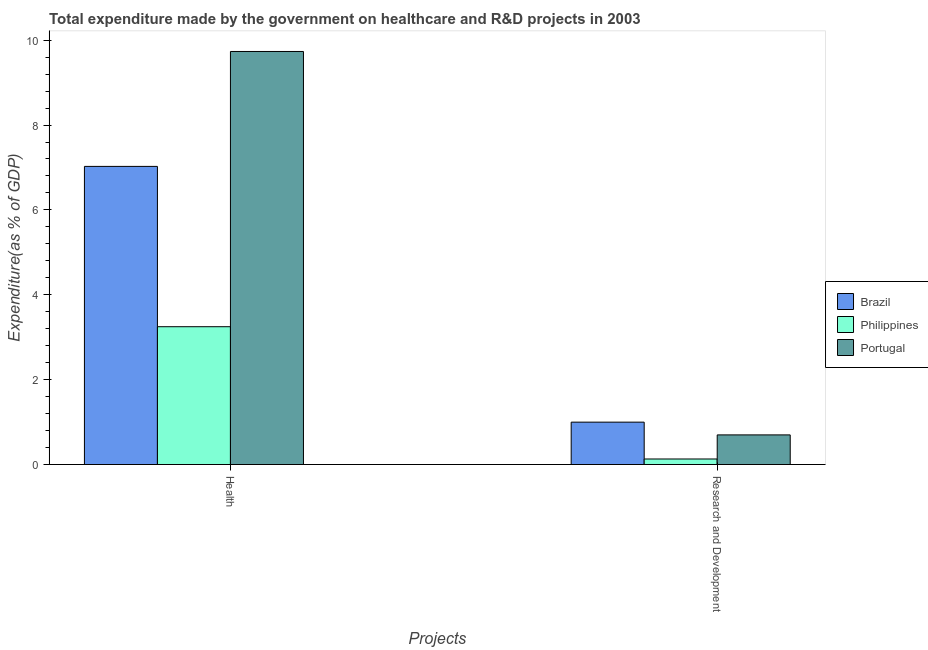Are the number of bars per tick equal to the number of legend labels?
Ensure brevity in your answer.  Yes. Are the number of bars on each tick of the X-axis equal?
Your answer should be compact. Yes. How many bars are there on the 1st tick from the left?
Offer a terse response. 3. What is the label of the 2nd group of bars from the left?
Make the answer very short. Research and Development. What is the expenditure in healthcare in Brazil?
Give a very brief answer. 7.03. Across all countries, what is the maximum expenditure in r&d?
Give a very brief answer. 1. Across all countries, what is the minimum expenditure in healthcare?
Offer a terse response. 3.25. In which country was the expenditure in healthcare maximum?
Provide a short and direct response. Portugal. In which country was the expenditure in r&d minimum?
Ensure brevity in your answer.  Philippines. What is the total expenditure in r&d in the graph?
Make the answer very short. 1.83. What is the difference between the expenditure in healthcare in Brazil and that in Portugal?
Give a very brief answer. -2.71. What is the difference between the expenditure in healthcare in Philippines and the expenditure in r&d in Portugal?
Keep it short and to the point. 2.55. What is the average expenditure in healthcare per country?
Give a very brief answer. 6.67. What is the difference between the expenditure in healthcare and expenditure in r&d in Portugal?
Ensure brevity in your answer.  9.04. In how many countries, is the expenditure in healthcare greater than 7.2 %?
Your response must be concise. 1. What is the ratio of the expenditure in r&d in Portugal to that in Philippines?
Your response must be concise. 5.37. Is the expenditure in healthcare in Portugal less than that in Brazil?
Ensure brevity in your answer.  No. In how many countries, is the expenditure in r&d greater than the average expenditure in r&d taken over all countries?
Provide a succinct answer. 2. What does the 3rd bar from the right in Health represents?
Give a very brief answer. Brazil. Are all the bars in the graph horizontal?
Provide a succinct answer. No. What is the difference between two consecutive major ticks on the Y-axis?
Offer a terse response. 2. Does the graph contain grids?
Your answer should be very brief. No. Where does the legend appear in the graph?
Provide a succinct answer. Center right. How many legend labels are there?
Provide a succinct answer. 3. What is the title of the graph?
Provide a short and direct response. Total expenditure made by the government on healthcare and R&D projects in 2003. What is the label or title of the X-axis?
Ensure brevity in your answer.  Projects. What is the label or title of the Y-axis?
Provide a succinct answer. Expenditure(as % of GDP). What is the Expenditure(as % of GDP) of Brazil in Health?
Offer a terse response. 7.03. What is the Expenditure(as % of GDP) in Philippines in Health?
Offer a very short reply. 3.25. What is the Expenditure(as % of GDP) of Portugal in Health?
Your answer should be very brief. 9.73. What is the Expenditure(as % of GDP) in Brazil in Research and Development?
Offer a terse response. 1. What is the Expenditure(as % of GDP) in Philippines in Research and Development?
Offer a very short reply. 0.13. What is the Expenditure(as % of GDP) in Portugal in Research and Development?
Provide a short and direct response. 0.7. Across all Projects, what is the maximum Expenditure(as % of GDP) in Brazil?
Offer a terse response. 7.03. Across all Projects, what is the maximum Expenditure(as % of GDP) of Philippines?
Provide a succinct answer. 3.25. Across all Projects, what is the maximum Expenditure(as % of GDP) in Portugal?
Make the answer very short. 9.73. Across all Projects, what is the minimum Expenditure(as % of GDP) in Brazil?
Your answer should be compact. 1. Across all Projects, what is the minimum Expenditure(as % of GDP) of Philippines?
Your response must be concise. 0.13. Across all Projects, what is the minimum Expenditure(as % of GDP) of Portugal?
Your answer should be compact. 0.7. What is the total Expenditure(as % of GDP) in Brazil in the graph?
Give a very brief answer. 8.02. What is the total Expenditure(as % of GDP) of Philippines in the graph?
Make the answer very short. 3.38. What is the total Expenditure(as % of GDP) in Portugal in the graph?
Your answer should be very brief. 10.43. What is the difference between the Expenditure(as % of GDP) in Brazil in Health and that in Research and Development?
Keep it short and to the point. 6.03. What is the difference between the Expenditure(as % of GDP) of Philippines in Health and that in Research and Development?
Your answer should be compact. 3.12. What is the difference between the Expenditure(as % of GDP) in Portugal in Health and that in Research and Development?
Your answer should be compact. 9.04. What is the difference between the Expenditure(as % of GDP) in Brazil in Health and the Expenditure(as % of GDP) in Philippines in Research and Development?
Your answer should be compact. 6.9. What is the difference between the Expenditure(as % of GDP) of Brazil in Health and the Expenditure(as % of GDP) of Portugal in Research and Development?
Give a very brief answer. 6.33. What is the difference between the Expenditure(as % of GDP) of Philippines in Health and the Expenditure(as % of GDP) of Portugal in Research and Development?
Ensure brevity in your answer.  2.55. What is the average Expenditure(as % of GDP) in Brazil per Projects?
Make the answer very short. 4.01. What is the average Expenditure(as % of GDP) of Philippines per Projects?
Offer a terse response. 1.69. What is the average Expenditure(as % of GDP) of Portugal per Projects?
Provide a succinct answer. 5.22. What is the difference between the Expenditure(as % of GDP) of Brazil and Expenditure(as % of GDP) of Philippines in Health?
Provide a succinct answer. 3.78. What is the difference between the Expenditure(as % of GDP) in Brazil and Expenditure(as % of GDP) in Portugal in Health?
Provide a succinct answer. -2.71. What is the difference between the Expenditure(as % of GDP) of Philippines and Expenditure(as % of GDP) of Portugal in Health?
Your answer should be very brief. -6.49. What is the difference between the Expenditure(as % of GDP) in Brazil and Expenditure(as % of GDP) in Philippines in Research and Development?
Your answer should be very brief. 0.87. What is the difference between the Expenditure(as % of GDP) of Brazil and Expenditure(as % of GDP) of Portugal in Research and Development?
Give a very brief answer. 0.3. What is the difference between the Expenditure(as % of GDP) in Philippines and Expenditure(as % of GDP) in Portugal in Research and Development?
Provide a short and direct response. -0.57. What is the ratio of the Expenditure(as % of GDP) of Brazil in Health to that in Research and Development?
Your answer should be very brief. 7.04. What is the ratio of the Expenditure(as % of GDP) of Philippines in Health to that in Research and Development?
Give a very brief answer. 24.99. What is the ratio of the Expenditure(as % of GDP) of Portugal in Health to that in Research and Development?
Provide a short and direct response. 13.95. What is the difference between the highest and the second highest Expenditure(as % of GDP) in Brazil?
Offer a terse response. 6.03. What is the difference between the highest and the second highest Expenditure(as % of GDP) of Philippines?
Your answer should be very brief. 3.12. What is the difference between the highest and the second highest Expenditure(as % of GDP) in Portugal?
Give a very brief answer. 9.04. What is the difference between the highest and the lowest Expenditure(as % of GDP) of Brazil?
Offer a very short reply. 6.03. What is the difference between the highest and the lowest Expenditure(as % of GDP) of Philippines?
Provide a short and direct response. 3.12. What is the difference between the highest and the lowest Expenditure(as % of GDP) in Portugal?
Keep it short and to the point. 9.04. 